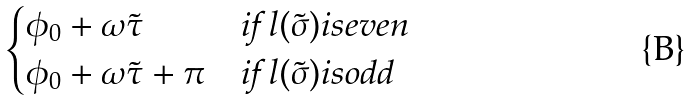<formula> <loc_0><loc_0><loc_500><loc_500>\begin{cases} \phi _ { 0 } + \omega \tilde { \tau } & \text {if } l ( \tilde { \sigma } ) i s e v e n \\ \phi _ { 0 } + \omega \tilde { \tau } + \pi & \text {if } l ( \tilde { \sigma } ) i s o d d \end{cases}</formula> 